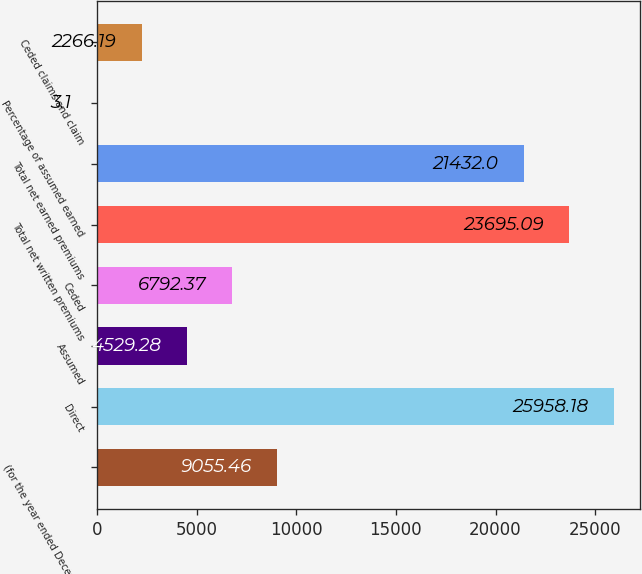Convert chart. <chart><loc_0><loc_0><loc_500><loc_500><bar_chart><fcel>(for the year ended December<fcel>Direct<fcel>Assumed<fcel>Ceded<fcel>Total net written premiums<fcel>Total net earned premiums<fcel>Percentage of assumed earned<fcel>Ceded claims and claim<nl><fcel>9055.46<fcel>25958.2<fcel>4529.28<fcel>6792.37<fcel>23695.1<fcel>21432<fcel>3.1<fcel>2266.19<nl></chart> 